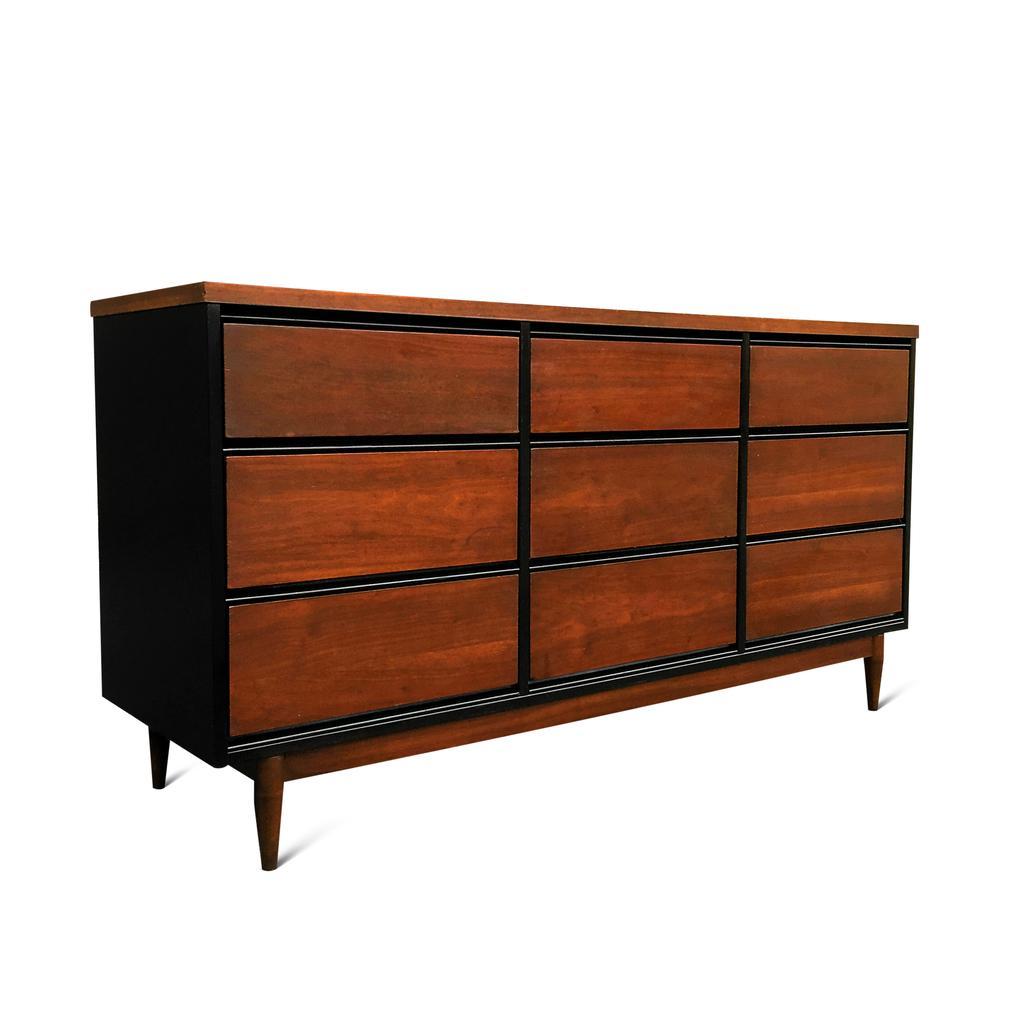Please provide a concise description of this image. In this image i can see a brown color wooden block 